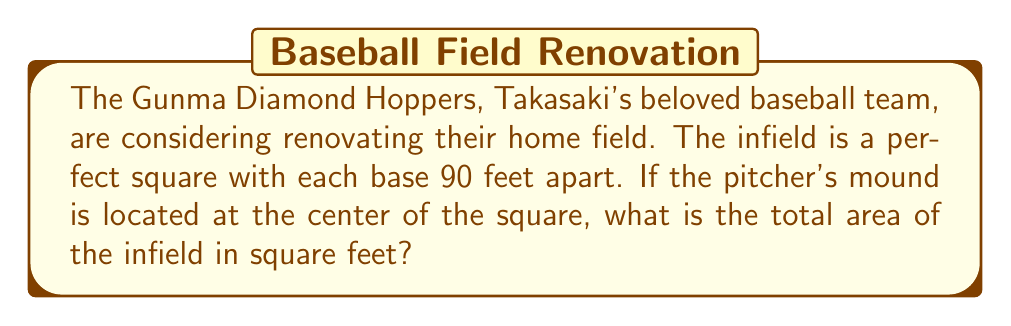What is the answer to this math problem? Let's approach this step-by-step:

1) First, we need to visualize the baseball diamond. It's a square with bases at each corner.

[asy]
unitsize(1cm);
pair A=(0,0), B=(4,0), C=(4,4), D=(0,4);
draw(A--B--C--D--cycle);
dot(A); dot(B); dot(C); dot(D);
label("Home", A, SW);
label("1st", B, SE);
label("2nd", C, NE);
label("3rd", D, NW);
dot((2,2));
label("Pitcher", (2,2), S);
[/asy]

2) We're told that each base is 90 feet apart. This means that the side length of the square is 90 feet.

3) To calculate the area of a square, we use the formula:

   $$A = s^2$$

   Where $A$ is the area and $s$ is the side length.

4) Plugging in our value:

   $$A = 90^2 = 8100$$

5) Therefore, the area of the infield is 8100 square feet.
Answer: 8100 sq ft 